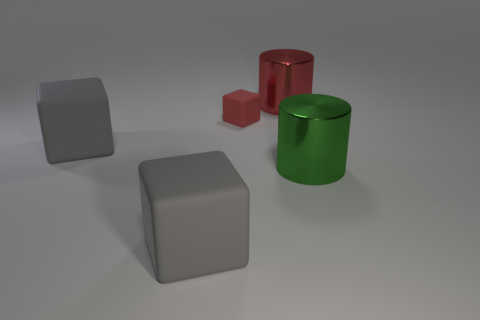Subtract 2 cylinders. How many cylinders are left? 0 Add 4 large cylinders. How many objects exist? 9 Subtract all gray cubes. How many cubes are left? 1 Subtract all cubes. How many objects are left? 2 Subtract all red cylinders. How many cylinders are left? 1 Subtract all gray cylinders. Subtract all gray balls. How many cylinders are left? 2 Subtract all cyan blocks. How many red cylinders are left? 1 Subtract all tiny yellow matte cylinders. Subtract all big gray cubes. How many objects are left? 3 Add 3 large red things. How many large red things are left? 4 Add 4 tiny red objects. How many tiny red objects exist? 5 